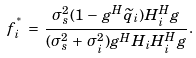<formula> <loc_0><loc_0><loc_500><loc_500>\, f _ { i } ^ { ^ { * } } \, = \, \frac { \sigma _ { s } ^ { 2 } ( 1 \, - \, g ^ { H } \widetilde { q } _ { i } ) H _ { i } ^ { H } g } { ( \sigma _ { s } ^ { 2 } \, + \, \sigma _ { i } ^ { 2 } ) g ^ { H } H _ { i } H _ { i } ^ { H } g } .</formula> 